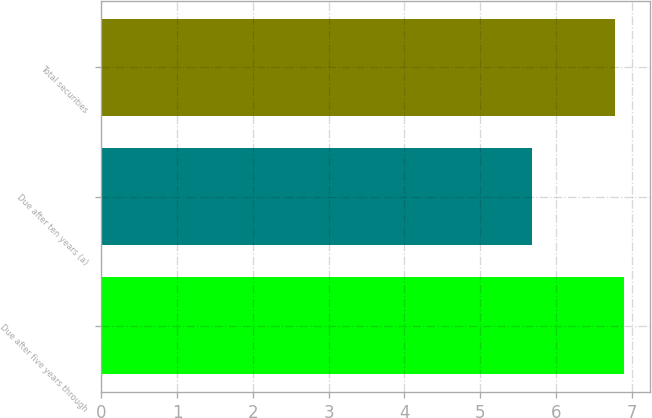Convert chart. <chart><loc_0><loc_0><loc_500><loc_500><bar_chart><fcel>Due after five years through<fcel>Due after ten years (a)<fcel>Total securities<nl><fcel>6.9<fcel>5.69<fcel>6.78<nl></chart> 